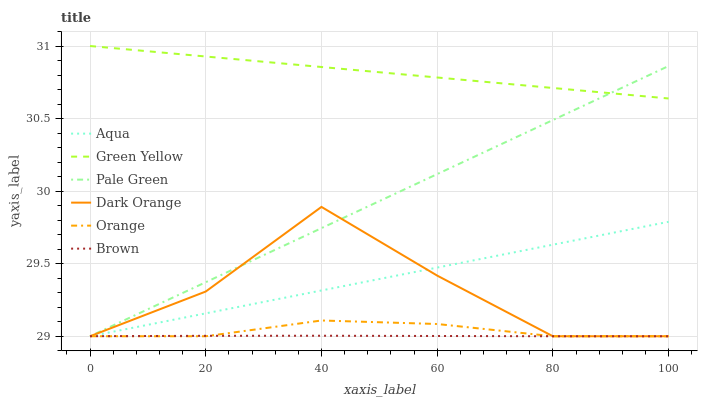Does Brown have the minimum area under the curve?
Answer yes or no. Yes. Does Green Yellow have the maximum area under the curve?
Answer yes or no. Yes. Does Dark Orange have the minimum area under the curve?
Answer yes or no. No. Does Dark Orange have the maximum area under the curve?
Answer yes or no. No. Is Aqua the smoothest?
Answer yes or no. Yes. Is Dark Orange the roughest?
Answer yes or no. Yes. Is Dark Orange the smoothest?
Answer yes or no. No. Is Aqua the roughest?
Answer yes or no. No. Does Green Yellow have the lowest value?
Answer yes or no. No. Does Dark Orange have the highest value?
Answer yes or no. No. Is Orange less than Green Yellow?
Answer yes or no. Yes. Is Green Yellow greater than Brown?
Answer yes or no. Yes. Does Orange intersect Green Yellow?
Answer yes or no. No. 